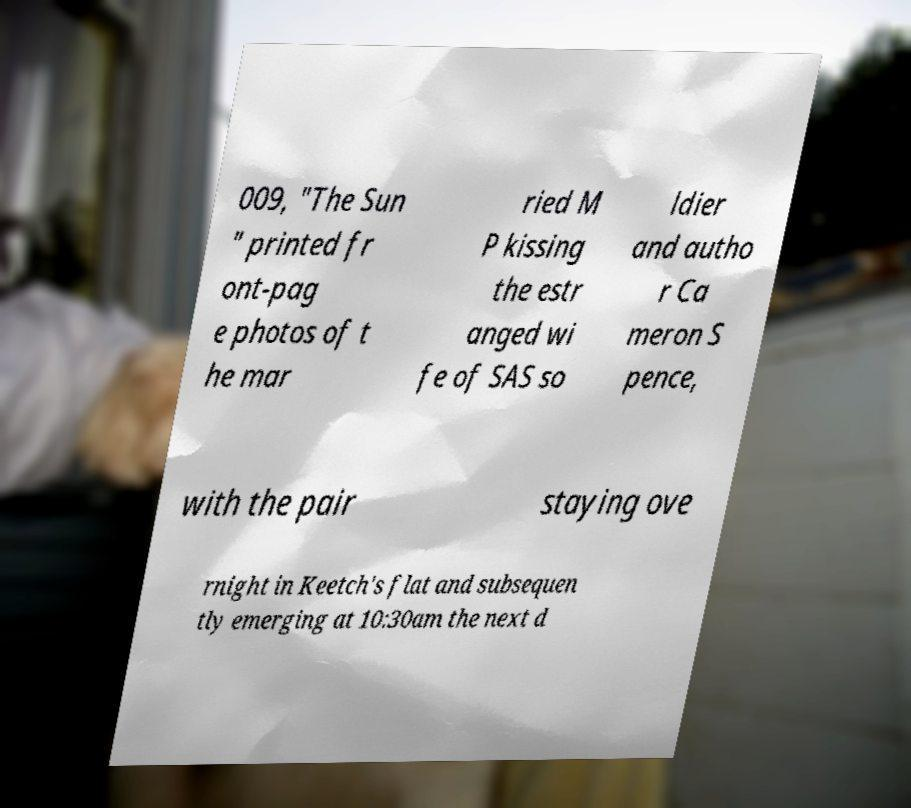There's text embedded in this image that I need extracted. Can you transcribe it verbatim? 009, "The Sun " printed fr ont-pag e photos of t he mar ried M P kissing the estr anged wi fe of SAS so ldier and autho r Ca meron S pence, with the pair staying ove rnight in Keetch's flat and subsequen tly emerging at 10:30am the next d 